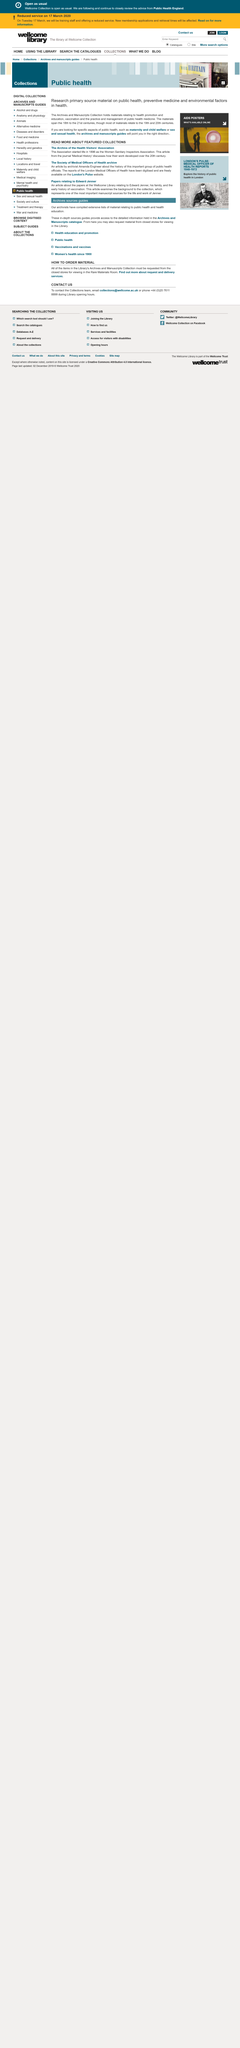Mention a couple of crucial points in this snapshot. The digitized versions of the reports of the London Medical Officers of Health are available for free on the London's Pulse website. The papers relating to Edward Jenner can be found at the Welcome Library. The Archive of the Health Visitors' Association was previously known as the Women Sanitary Inspectors Association. 